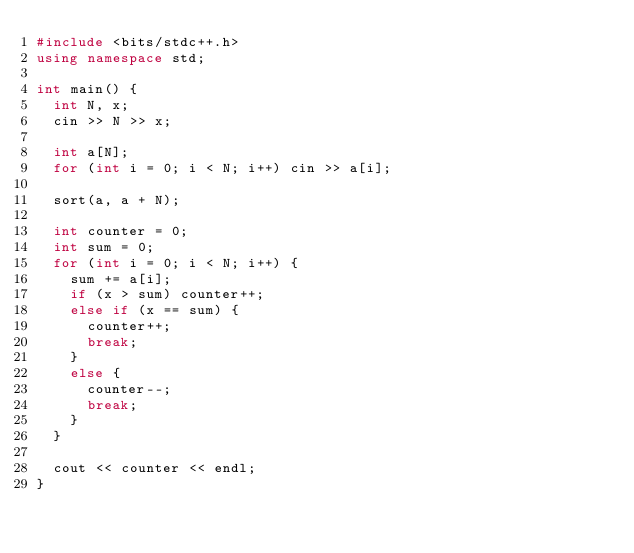<code> <loc_0><loc_0><loc_500><loc_500><_C++_>#include <bits/stdc++.h>
using namespace std;

int main() {
  int N, x;
  cin >> N >> x;

  int a[N];
  for (int i = 0; i < N; i++) cin >> a[i];

  sort(a, a + N);

  int counter = 0;
  int sum = 0;
  for (int i = 0; i < N; i++) {
    sum += a[i];
    if (x > sum) counter++;
    else if (x == sum) {
      counter++;
      break;
    }
    else {
      counter--;
      break;
    }
  }

  cout << counter << endl;
}</code> 